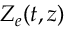Convert formula to latex. <formula><loc_0><loc_0><loc_500><loc_500>Z _ { e } ( t , z )</formula> 